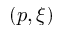<formula> <loc_0><loc_0><loc_500><loc_500>( p , \xi )</formula> 